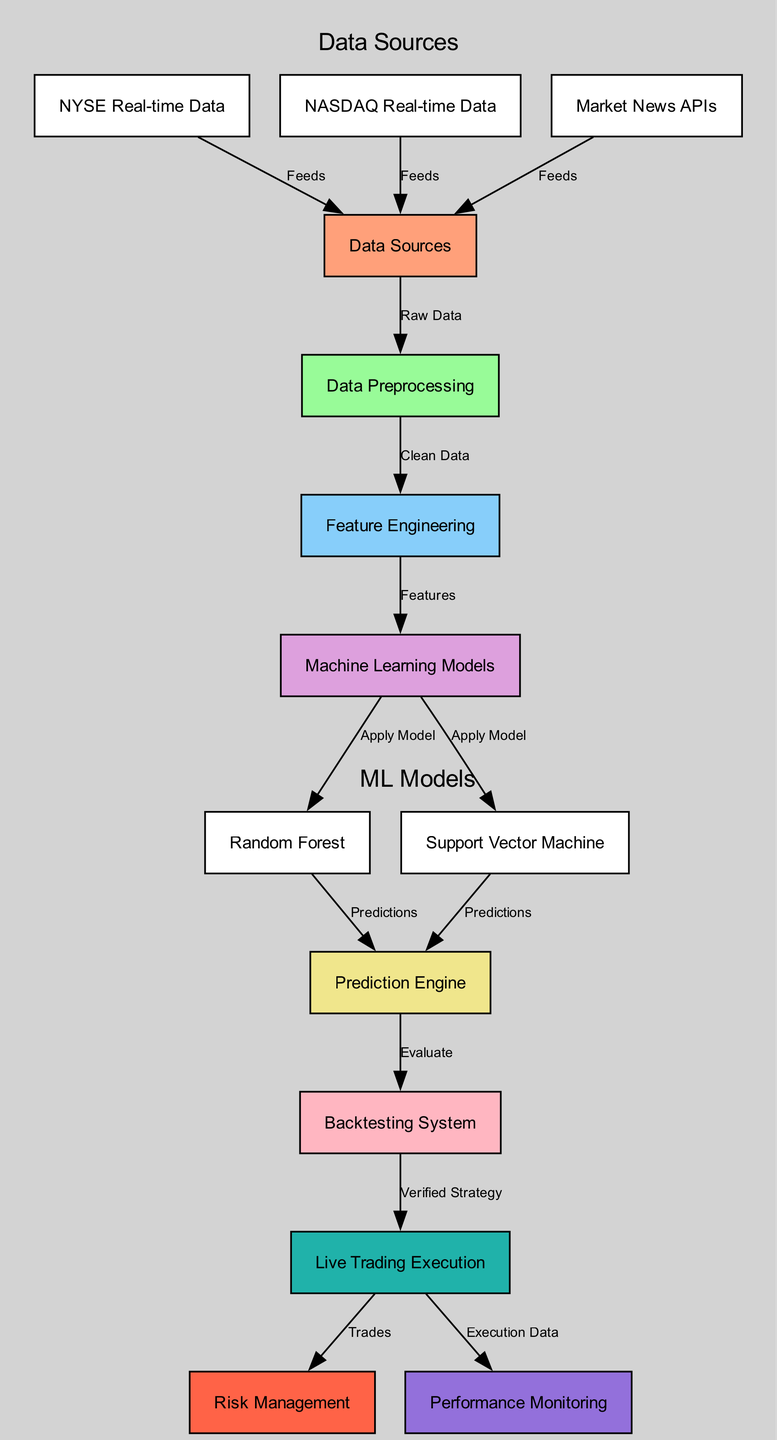What are the data sources feeding into the system? The nodes labeled 'NYSE Real-time Data,' 'NASDAQ Real-time Data,' and 'Market News APIs' are directly connected to 'Data Sources' with the label 'Feeds.' These sources provide the raw data necessary for the entire process.
Answer: NYSE Real-time Data, NASDAQ Real-time Data, Market News APIs How many machine learning models are shown in the diagram? The diagram features nodes connected to 'Machine Learning Models' that include 'Random Forest' and 'Support Vector Machine.' Counting these gives us the total number of models presented in the diagram.
Answer: 2 What is the output from the 'Prediction Engine'? The 'Prediction Engine' node receives input from both 'Random Forest' and 'Support Vector Machine' nodes, producing output labeled 'Predictions' which is then sent to 'Backtesting System.' This identifies the specific result produced at this stage.
Answer: Predictions What are the two subsequent processes following 'Data Preprocessing'? The diagram shows that after 'Data Preprocessing,' the flow leads to 'Feature Engineering' first, followed by 'Machine Learning Models.' These steps indicate the immediate actions taken post-data manipulation.
Answer: Feature Engineering, Machine Learning Models Which systems are directly linked to 'Live Trading Execution'? The 'Live Trading Execution' node has direct connections labeled 'Trades' to 'Risk Management' and 'Execution Data' to 'Performance Monitoring.' This shows the two systems integrated right after executing trades.
Answer: Risk Management, Performance Monitoring In what sequence do the models apply their predictions? The models 'Random Forest' and 'Support Vector Machine' apply their predictions to the 'Prediction Engine' following the feature engineering output. This depicts the order in which the models contribute their predictions for evaluation.
Answer: Random Forest, Support Vector Machine What type of data is processed before entering the 'Feature Engineering' node? The 'Data Preprocessing' node receives 'Raw Data' from 'Data Sources' and outputs 'Clean Data' for 'Feature Engineering.' This outlines the nature of the data processed prior to feature extraction.
Answer: Clean Data Which component validates the trading strategies before live execution? The 'Backtesting System' receives evaluations from the 'Prediction Engine' and is responsible for verifying strategies before they reach the 'Live Trading Execution' stage. This indicates its role in quality assurance before trading.
Answer: Backtesting System 